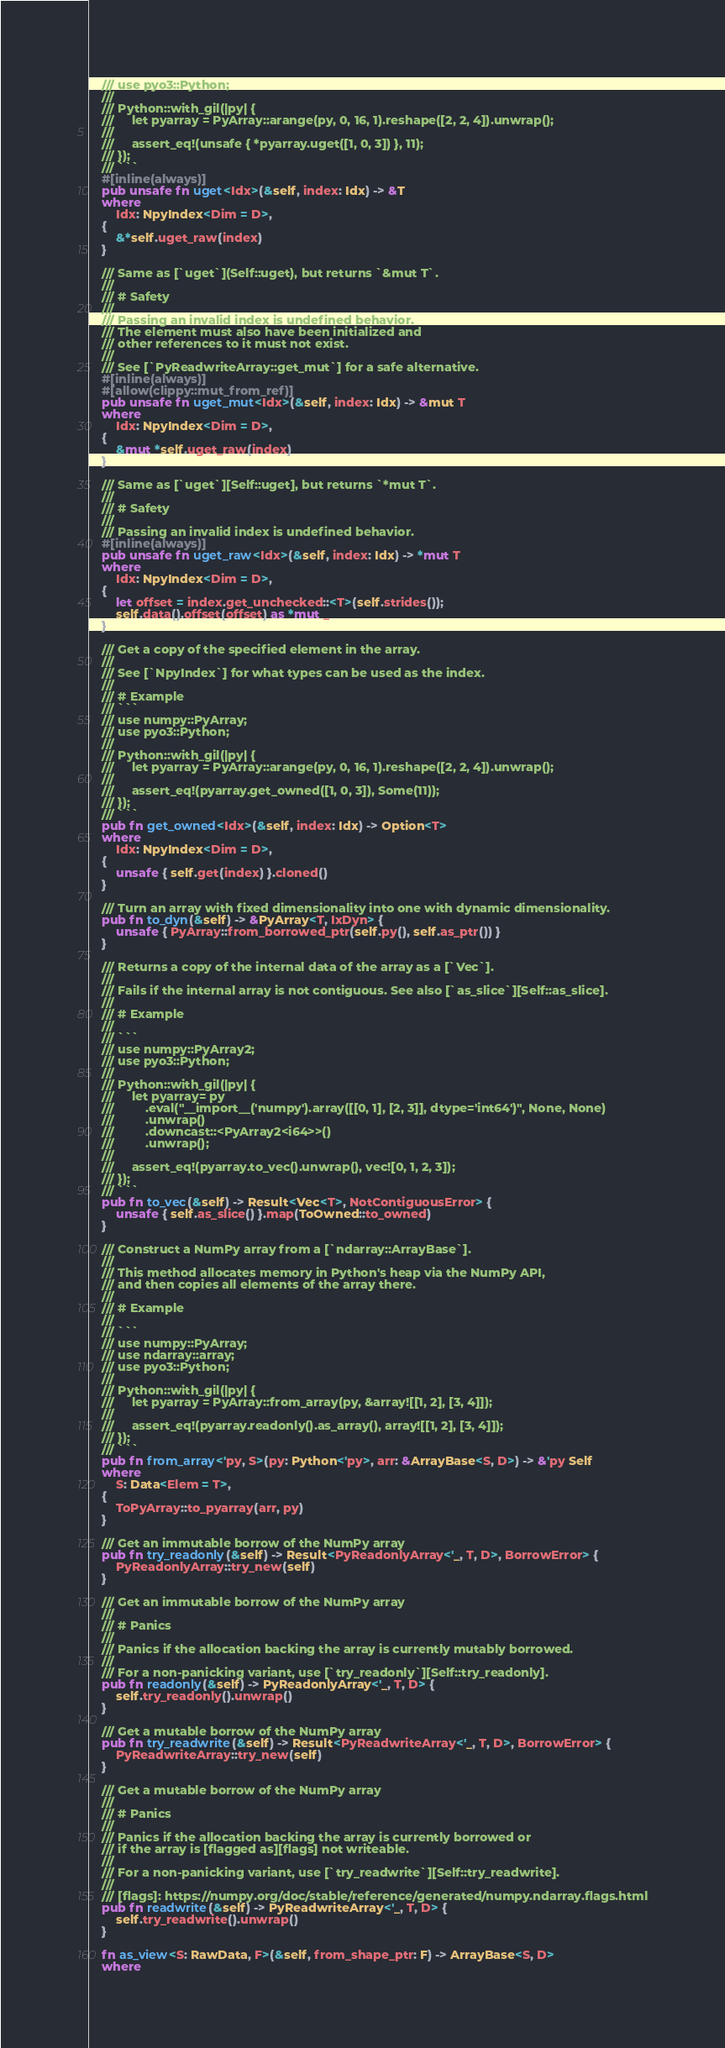Convert code to text. <code><loc_0><loc_0><loc_500><loc_500><_Rust_>    /// use pyo3::Python;
    ///
    /// Python::with_gil(|py| {
    ///     let pyarray = PyArray::arange(py, 0, 16, 1).reshape([2, 2, 4]).unwrap();
    ///
    ///     assert_eq!(unsafe { *pyarray.uget([1, 0, 3]) }, 11);
    /// });
    /// ```
    #[inline(always)]
    pub unsafe fn uget<Idx>(&self, index: Idx) -> &T
    where
        Idx: NpyIndex<Dim = D>,
    {
        &*self.uget_raw(index)
    }

    /// Same as [`uget`](Self::uget), but returns `&mut T`.
    ///
    /// # Safety
    ///
    /// Passing an invalid index is undefined behavior.
    /// The element must also have been initialized and
    /// other references to it must not exist.
    ///
    /// See [`PyReadwriteArray::get_mut`] for a safe alternative.
    #[inline(always)]
    #[allow(clippy::mut_from_ref)]
    pub unsafe fn uget_mut<Idx>(&self, index: Idx) -> &mut T
    where
        Idx: NpyIndex<Dim = D>,
    {
        &mut *self.uget_raw(index)
    }

    /// Same as [`uget`][Self::uget], but returns `*mut T`.
    ///
    /// # Safety
    ///
    /// Passing an invalid index is undefined behavior.
    #[inline(always)]
    pub unsafe fn uget_raw<Idx>(&self, index: Idx) -> *mut T
    where
        Idx: NpyIndex<Dim = D>,
    {
        let offset = index.get_unchecked::<T>(self.strides());
        self.data().offset(offset) as *mut _
    }

    /// Get a copy of the specified element in the array.
    ///
    /// See [`NpyIndex`] for what types can be used as the index.
    ///
    /// # Example
    /// ```
    /// use numpy::PyArray;
    /// use pyo3::Python;
    ///
    /// Python::with_gil(|py| {
    ///     let pyarray = PyArray::arange(py, 0, 16, 1).reshape([2, 2, 4]).unwrap();
    ///
    ///     assert_eq!(pyarray.get_owned([1, 0, 3]), Some(11));
    /// });
    /// ```
    pub fn get_owned<Idx>(&self, index: Idx) -> Option<T>
    where
        Idx: NpyIndex<Dim = D>,
    {
        unsafe { self.get(index) }.cloned()
    }

    /// Turn an array with fixed dimensionality into one with dynamic dimensionality.
    pub fn to_dyn(&self) -> &PyArray<T, IxDyn> {
        unsafe { PyArray::from_borrowed_ptr(self.py(), self.as_ptr()) }
    }

    /// Returns a copy of the internal data of the array as a [`Vec`].
    ///
    /// Fails if the internal array is not contiguous. See also [`as_slice`][Self::as_slice].
    ///
    /// # Example
    ///
    /// ```
    /// use numpy::PyArray2;
    /// use pyo3::Python;
    ///
    /// Python::with_gil(|py| {
    ///     let pyarray= py
    ///         .eval("__import__('numpy').array([[0, 1], [2, 3]], dtype='int64')", None, None)
    ///         .unwrap()
    ///         .downcast::<PyArray2<i64>>()
    ///         .unwrap();
    ///
    ///     assert_eq!(pyarray.to_vec().unwrap(), vec![0, 1, 2, 3]);
    /// });
    /// ```
    pub fn to_vec(&self) -> Result<Vec<T>, NotContiguousError> {
        unsafe { self.as_slice() }.map(ToOwned::to_owned)
    }

    /// Construct a NumPy array from a [`ndarray::ArrayBase`].
    ///
    /// This method allocates memory in Python's heap via the NumPy API,
    /// and then copies all elements of the array there.
    ///
    /// # Example
    ///
    /// ```
    /// use numpy::PyArray;
    /// use ndarray::array;
    /// use pyo3::Python;
    ///
    /// Python::with_gil(|py| {
    ///     let pyarray = PyArray::from_array(py, &array![[1, 2], [3, 4]]);
    ///
    ///     assert_eq!(pyarray.readonly().as_array(), array![[1, 2], [3, 4]]);
    /// });
    /// ```
    pub fn from_array<'py, S>(py: Python<'py>, arr: &ArrayBase<S, D>) -> &'py Self
    where
        S: Data<Elem = T>,
    {
        ToPyArray::to_pyarray(arr, py)
    }

    /// Get an immutable borrow of the NumPy array
    pub fn try_readonly(&self) -> Result<PyReadonlyArray<'_, T, D>, BorrowError> {
        PyReadonlyArray::try_new(self)
    }

    /// Get an immutable borrow of the NumPy array
    ///
    /// # Panics
    ///
    /// Panics if the allocation backing the array is currently mutably borrowed.
    ///
    /// For a non-panicking variant, use [`try_readonly`][Self::try_readonly].
    pub fn readonly(&self) -> PyReadonlyArray<'_, T, D> {
        self.try_readonly().unwrap()
    }

    /// Get a mutable borrow of the NumPy array
    pub fn try_readwrite(&self) -> Result<PyReadwriteArray<'_, T, D>, BorrowError> {
        PyReadwriteArray::try_new(self)
    }

    /// Get a mutable borrow of the NumPy array
    ///
    /// # Panics
    ///
    /// Panics if the allocation backing the array is currently borrowed or
    /// if the array is [flagged as][flags] not writeable.
    ///
    /// For a non-panicking variant, use [`try_readwrite`][Self::try_readwrite].
    ///
    /// [flags]: https://numpy.org/doc/stable/reference/generated/numpy.ndarray.flags.html
    pub fn readwrite(&self) -> PyReadwriteArray<'_, T, D> {
        self.try_readwrite().unwrap()
    }

    fn as_view<S: RawData, F>(&self, from_shape_ptr: F) -> ArrayBase<S, D>
    where</code> 